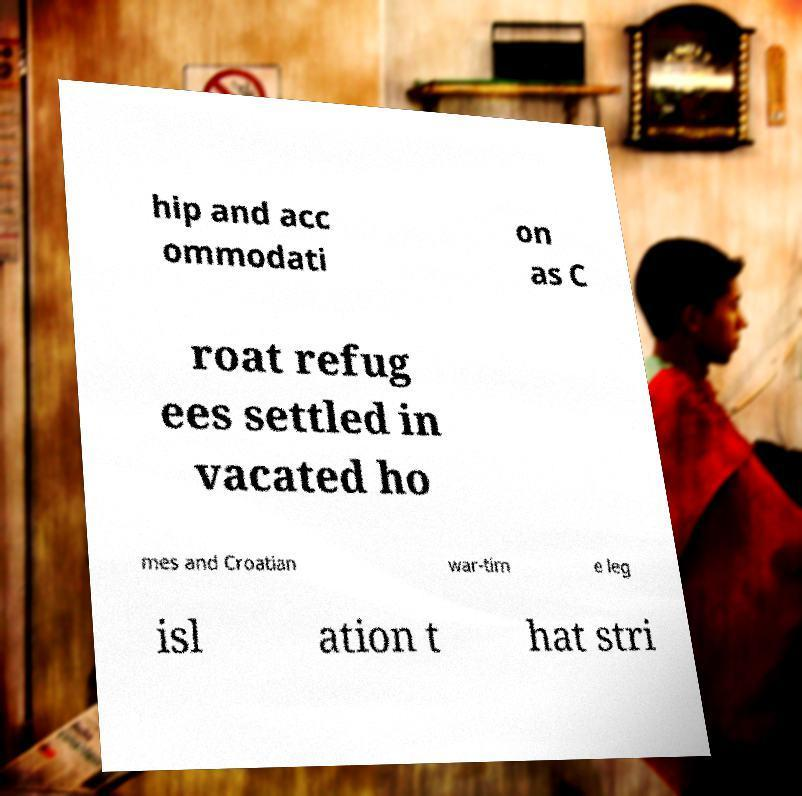There's text embedded in this image that I need extracted. Can you transcribe it verbatim? hip and acc ommodati on as C roat refug ees settled in vacated ho mes and Croatian war-tim e leg isl ation t hat stri 